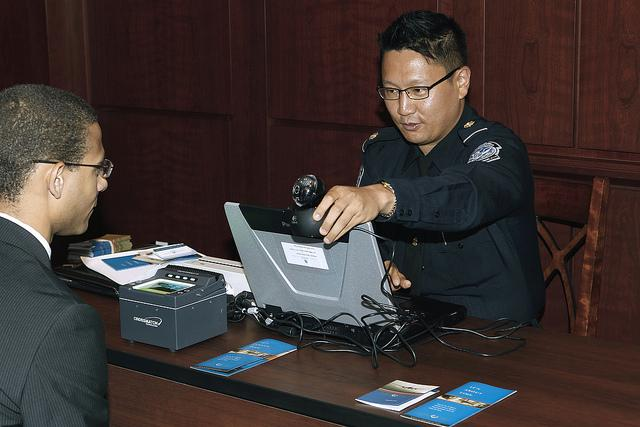What is the person with the laptop taking? Please explain your reasoning. photograph. The man is adjusting a webcam and orientating it towards the person sitting across from him. a web cam would be used to capture answer a and the man would likely need to re-position it based on the person across from him. 